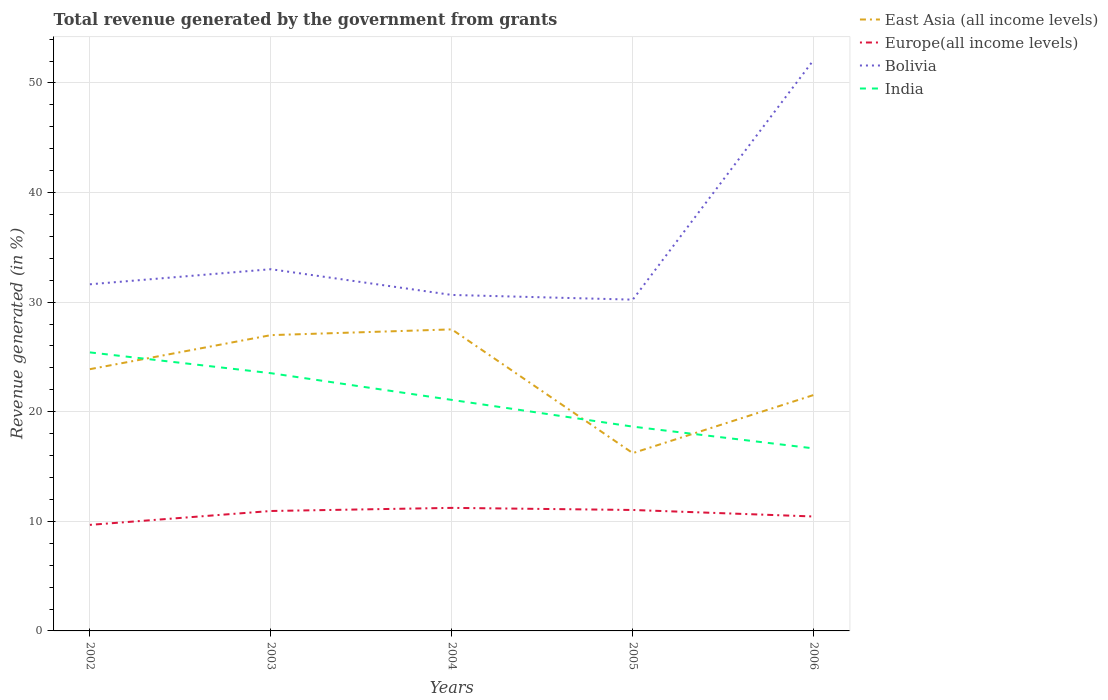How many different coloured lines are there?
Your answer should be compact. 4. Across all years, what is the maximum total revenue generated in India?
Your answer should be compact. 16.65. What is the total total revenue generated in Europe(all income levels) in the graph?
Offer a terse response. -0.76. What is the difference between the highest and the second highest total revenue generated in East Asia (all income levels)?
Your answer should be very brief. 11.29. Is the total revenue generated in India strictly greater than the total revenue generated in Bolivia over the years?
Give a very brief answer. Yes. What is the difference between two consecutive major ticks on the Y-axis?
Your response must be concise. 10. Does the graph contain any zero values?
Ensure brevity in your answer.  No. Does the graph contain grids?
Your answer should be very brief. Yes. How many legend labels are there?
Offer a very short reply. 4. What is the title of the graph?
Offer a terse response. Total revenue generated by the government from grants. What is the label or title of the Y-axis?
Provide a succinct answer. Revenue generated (in %). What is the Revenue generated (in %) of East Asia (all income levels) in 2002?
Give a very brief answer. 23.88. What is the Revenue generated (in %) of Europe(all income levels) in 2002?
Provide a succinct answer. 9.68. What is the Revenue generated (in %) of Bolivia in 2002?
Your answer should be compact. 31.63. What is the Revenue generated (in %) in India in 2002?
Ensure brevity in your answer.  25.41. What is the Revenue generated (in %) in East Asia (all income levels) in 2003?
Your response must be concise. 26.99. What is the Revenue generated (in %) of Europe(all income levels) in 2003?
Your answer should be compact. 10.94. What is the Revenue generated (in %) in Bolivia in 2003?
Keep it short and to the point. 33. What is the Revenue generated (in %) of India in 2003?
Offer a terse response. 23.52. What is the Revenue generated (in %) of East Asia (all income levels) in 2004?
Your answer should be very brief. 27.51. What is the Revenue generated (in %) in Europe(all income levels) in 2004?
Provide a succinct answer. 11.23. What is the Revenue generated (in %) in Bolivia in 2004?
Make the answer very short. 30.66. What is the Revenue generated (in %) of India in 2004?
Offer a very short reply. 21.08. What is the Revenue generated (in %) in East Asia (all income levels) in 2005?
Ensure brevity in your answer.  16.22. What is the Revenue generated (in %) of Europe(all income levels) in 2005?
Ensure brevity in your answer.  11.04. What is the Revenue generated (in %) of Bolivia in 2005?
Your answer should be compact. 30.23. What is the Revenue generated (in %) of India in 2005?
Provide a succinct answer. 18.64. What is the Revenue generated (in %) of East Asia (all income levels) in 2006?
Offer a very short reply. 21.53. What is the Revenue generated (in %) in Europe(all income levels) in 2006?
Make the answer very short. 10.44. What is the Revenue generated (in %) of Bolivia in 2006?
Your answer should be compact. 52.11. What is the Revenue generated (in %) of India in 2006?
Offer a very short reply. 16.65. Across all years, what is the maximum Revenue generated (in %) in East Asia (all income levels)?
Give a very brief answer. 27.51. Across all years, what is the maximum Revenue generated (in %) of Europe(all income levels)?
Offer a very short reply. 11.23. Across all years, what is the maximum Revenue generated (in %) in Bolivia?
Offer a very short reply. 52.11. Across all years, what is the maximum Revenue generated (in %) in India?
Your answer should be very brief. 25.41. Across all years, what is the minimum Revenue generated (in %) in East Asia (all income levels)?
Give a very brief answer. 16.22. Across all years, what is the minimum Revenue generated (in %) of Europe(all income levels)?
Offer a very short reply. 9.68. Across all years, what is the minimum Revenue generated (in %) of Bolivia?
Make the answer very short. 30.23. Across all years, what is the minimum Revenue generated (in %) of India?
Your answer should be very brief. 16.65. What is the total Revenue generated (in %) in East Asia (all income levels) in the graph?
Your response must be concise. 116.13. What is the total Revenue generated (in %) in Europe(all income levels) in the graph?
Ensure brevity in your answer.  53.32. What is the total Revenue generated (in %) in Bolivia in the graph?
Provide a short and direct response. 177.62. What is the total Revenue generated (in %) of India in the graph?
Your answer should be very brief. 105.3. What is the difference between the Revenue generated (in %) of East Asia (all income levels) in 2002 and that in 2003?
Give a very brief answer. -3.11. What is the difference between the Revenue generated (in %) of Europe(all income levels) in 2002 and that in 2003?
Provide a short and direct response. -1.27. What is the difference between the Revenue generated (in %) in Bolivia in 2002 and that in 2003?
Your response must be concise. -1.38. What is the difference between the Revenue generated (in %) in India in 2002 and that in 2003?
Offer a terse response. 1.9. What is the difference between the Revenue generated (in %) of East Asia (all income levels) in 2002 and that in 2004?
Keep it short and to the point. -3.63. What is the difference between the Revenue generated (in %) in Europe(all income levels) in 2002 and that in 2004?
Ensure brevity in your answer.  -1.55. What is the difference between the Revenue generated (in %) in India in 2002 and that in 2004?
Your response must be concise. 4.33. What is the difference between the Revenue generated (in %) of East Asia (all income levels) in 2002 and that in 2005?
Offer a terse response. 7.66. What is the difference between the Revenue generated (in %) in Europe(all income levels) in 2002 and that in 2005?
Ensure brevity in your answer.  -1.36. What is the difference between the Revenue generated (in %) of Bolivia in 2002 and that in 2005?
Offer a very short reply. 1.4. What is the difference between the Revenue generated (in %) in India in 2002 and that in 2005?
Offer a terse response. 6.77. What is the difference between the Revenue generated (in %) in East Asia (all income levels) in 2002 and that in 2006?
Provide a short and direct response. 2.35. What is the difference between the Revenue generated (in %) of Europe(all income levels) in 2002 and that in 2006?
Offer a very short reply. -0.76. What is the difference between the Revenue generated (in %) of Bolivia in 2002 and that in 2006?
Make the answer very short. -20.48. What is the difference between the Revenue generated (in %) in India in 2002 and that in 2006?
Your response must be concise. 8.76. What is the difference between the Revenue generated (in %) of East Asia (all income levels) in 2003 and that in 2004?
Provide a short and direct response. -0.52. What is the difference between the Revenue generated (in %) of Europe(all income levels) in 2003 and that in 2004?
Your answer should be very brief. -0.28. What is the difference between the Revenue generated (in %) of Bolivia in 2003 and that in 2004?
Keep it short and to the point. 2.35. What is the difference between the Revenue generated (in %) of India in 2003 and that in 2004?
Offer a terse response. 2.44. What is the difference between the Revenue generated (in %) in East Asia (all income levels) in 2003 and that in 2005?
Make the answer very short. 10.77. What is the difference between the Revenue generated (in %) of Europe(all income levels) in 2003 and that in 2005?
Your response must be concise. -0.09. What is the difference between the Revenue generated (in %) in Bolivia in 2003 and that in 2005?
Make the answer very short. 2.78. What is the difference between the Revenue generated (in %) of India in 2003 and that in 2005?
Offer a terse response. 4.88. What is the difference between the Revenue generated (in %) in East Asia (all income levels) in 2003 and that in 2006?
Offer a very short reply. 5.46. What is the difference between the Revenue generated (in %) in Europe(all income levels) in 2003 and that in 2006?
Provide a succinct answer. 0.5. What is the difference between the Revenue generated (in %) in Bolivia in 2003 and that in 2006?
Ensure brevity in your answer.  -19.1. What is the difference between the Revenue generated (in %) of India in 2003 and that in 2006?
Offer a very short reply. 6.86. What is the difference between the Revenue generated (in %) of East Asia (all income levels) in 2004 and that in 2005?
Ensure brevity in your answer.  11.29. What is the difference between the Revenue generated (in %) in Europe(all income levels) in 2004 and that in 2005?
Keep it short and to the point. 0.19. What is the difference between the Revenue generated (in %) in Bolivia in 2004 and that in 2005?
Provide a short and direct response. 0.43. What is the difference between the Revenue generated (in %) in India in 2004 and that in 2005?
Make the answer very short. 2.44. What is the difference between the Revenue generated (in %) of East Asia (all income levels) in 2004 and that in 2006?
Your answer should be compact. 5.98. What is the difference between the Revenue generated (in %) of Europe(all income levels) in 2004 and that in 2006?
Provide a short and direct response. 0.79. What is the difference between the Revenue generated (in %) in Bolivia in 2004 and that in 2006?
Provide a short and direct response. -21.45. What is the difference between the Revenue generated (in %) in India in 2004 and that in 2006?
Provide a succinct answer. 4.42. What is the difference between the Revenue generated (in %) of East Asia (all income levels) in 2005 and that in 2006?
Your answer should be compact. -5.31. What is the difference between the Revenue generated (in %) in Europe(all income levels) in 2005 and that in 2006?
Give a very brief answer. 0.59. What is the difference between the Revenue generated (in %) of Bolivia in 2005 and that in 2006?
Your response must be concise. -21.88. What is the difference between the Revenue generated (in %) of India in 2005 and that in 2006?
Offer a very short reply. 1.99. What is the difference between the Revenue generated (in %) in East Asia (all income levels) in 2002 and the Revenue generated (in %) in Europe(all income levels) in 2003?
Your response must be concise. 12.94. What is the difference between the Revenue generated (in %) of East Asia (all income levels) in 2002 and the Revenue generated (in %) of Bolivia in 2003?
Give a very brief answer. -9.12. What is the difference between the Revenue generated (in %) in East Asia (all income levels) in 2002 and the Revenue generated (in %) in India in 2003?
Offer a very short reply. 0.37. What is the difference between the Revenue generated (in %) of Europe(all income levels) in 2002 and the Revenue generated (in %) of Bolivia in 2003?
Offer a very short reply. -23.33. What is the difference between the Revenue generated (in %) of Europe(all income levels) in 2002 and the Revenue generated (in %) of India in 2003?
Your answer should be compact. -13.84. What is the difference between the Revenue generated (in %) in Bolivia in 2002 and the Revenue generated (in %) in India in 2003?
Keep it short and to the point. 8.11. What is the difference between the Revenue generated (in %) in East Asia (all income levels) in 2002 and the Revenue generated (in %) in Europe(all income levels) in 2004?
Provide a succinct answer. 12.65. What is the difference between the Revenue generated (in %) in East Asia (all income levels) in 2002 and the Revenue generated (in %) in Bolivia in 2004?
Provide a short and direct response. -6.77. What is the difference between the Revenue generated (in %) of East Asia (all income levels) in 2002 and the Revenue generated (in %) of India in 2004?
Provide a short and direct response. 2.8. What is the difference between the Revenue generated (in %) in Europe(all income levels) in 2002 and the Revenue generated (in %) in Bolivia in 2004?
Keep it short and to the point. -20.98. What is the difference between the Revenue generated (in %) of Europe(all income levels) in 2002 and the Revenue generated (in %) of India in 2004?
Provide a short and direct response. -11.4. What is the difference between the Revenue generated (in %) of Bolivia in 2002 and the Revenue generated (in %) of India in 2004?
Give a very brief answer. 10.55. What is the difference between the Revenue generated (in %) of East Asia (all income levels) in 2002 and the Revenue generated (in %) of Europe(all income levels) in 2005?
Give a very brief answer. 12.85. What is the difference between the Revenue generated (in %) in East Asia (all income levels) in 2002 and the Revenue generated (in %) in Bolivia in 2005?
Offer a very short reply. -6.34. What is the difference between the Revenue generated (in %) of East Asia (all income levels) in 2002 and the Revenue generated (in %) of India in 2005?
Provide a short and direct response. 5.24. What is the difference between the Revenue generated (in %) in Europe(all income levels) in 2002 and the Revenue generated (in %) in Bolivia in 2005?
Your response must be concise. -20.55. What is the difference between the Revenue generated (in %) in Europe(all income levels) in 2002 and the Revenue generated (in %) in India in 2005?
Provide a short and direct response. -8.96. What is the difference between the Revenue generated (in %) in Bolivia in 2002 and the Revenue generated (in %) in India in 2005?
Your answer should be compact. 12.99. What is the difference between the Revenue generated (in %) in East Asia (all income levels) in 2002 and the Revenue generated (in %) in Europe(all income levels) in 2006?
Provide a succinct answer. 13.44. What is the difference between the Revenue generated (in %) in East Asia (all income levels) in 2002 and the Revenue generated (in %) in Bolivia in 2006?
Make the answer very short. -28.23. What is the difference between the Revenue generated (in %) of East Asia (all income levels) in 2002 and the Revenue generated (in %) of India in 2006?
Provide a short and direct response. 7.23. What is the difference between the Revenue generated (in %) in Europe(all income levels) in 2002 and the Revenue generated (in %) in Bolivia in 2006?
Give a very brief answer. -42.43. What is the difference between the Revenue generated (in %) of Europe(all income levels) in 2002 and the Revenue generated (in %) of India in 2006?
Make the answer very short. -6.98. What is the difference between the Revenue generated (in %) of Bolivia in 2002 and the Revenue generated (in %) of India in 2006?
Make the answer very short. 14.97. What is the difference between the Revenue generated (in %) of East Asia (all income levels) in 2003 and the Revenue generated (in %) of Europe(all income levels) in 2004?
Your answer should be compact. 15.76. What is the difference between the Revenue generated (in %) of East Asia (all income levels) in 2003 and the Revenue generated (in %) of Bolivia in 2004?
Provide a succinct answer. -3.67. What is the difference between the Revenue generated (in %) in East Asia (all income levels) in 2003 and the Revenue generated (in %) in India in 2004?
Offer a very short reply. 5.91. What is the difference between the Revenue generated (in %) of Europe(all income levels) in 2003 and the Revenue generated (in %) of Bolivia in 2004?
Make the answer very short. -19.71. What is the difference between the Revenue generated (in %) in Europe(all income levels) in 2003 and the Revenue generated (in %) in India in 2004?
Your answer should be very brief. -10.14. What is the difference between the Revenue generated (in %) in Bolivia in 2003 and the Revenue generated (in %) in India in 2004?
Offer a terse response. 11.93. What is the difference between the Revenue generated (in %) of East Asia (all income levels) in 2003 and the Revenue generated (in %) of Europe(all income levels) in 2005?
Make the answer very short. 15.95. What is the difference between the Revenue generated (in %) of East Asia (all income levels) in 2003 and the Revenue generated (in %) of Bolivia in 2005?
Make the answer very short. -3.24. What is the difference between the Revenue generated (in %) in East Asia (all income levels) in 2003 and the Revenue generated (in %) in India in 2005?
Provide a succinct answer. 8.35. What is the difference between the Revenue generated (in %) in Europe(all income levels) in 2003 and the Revenue generated (in %) in Bolivia in 2005?
Your response must be concise. -19.28. What is the difference between the Revenue generated (in %) in Europe(all income levels) in 2003 and the Revenue generated (in %) in India in 2005?
Your response must be concise. -7.7. What is the difference between the Revenue generated (in %) in Bolivia in 2003 and the Revenue generated (in %) in India in 2005?
Keep it short and to the point. 14.36. What is the difference between the Revenue generated (in %) of East Asia (all income levels) in 2003 and the Revenue generated (in %) of Europe(all income levels) in 2006?
Make the answer very short. 16.55. What is the difference between the Revenue generated (in %) in East Asia (all income levels) in 2003 and the Revenue generated (in %) in Bolivia in 2006?
Keep it short and to the point. -25.12. What is the difference between the Revenue generated (in %) in East Asia (all income levels) in 2003 and the Revenue generated (in %) in India in 2006?
Offer a terse response. 10.33. What is the difference between the Revenue generated (in %) of Europe(all income levels) in 2003 and the Revenue generated (in %) of Bolivia in 2006?
Make the answer very short. -41.16. What is the difference between the Revenue generated (in %) of Europe(all income levels) in 2003 and the Revenue generated (in %) of India in 2006?
Offer a terse response. -5.71. What is the difference between the Revenue generated (in %) of Bolivia in 2003 and the Revenue generated (in %) of India in 2006?
Offer a terse response. 16.35. What is the difference between the Revenue generated (in %) of East Asia (all income levels) in 2004 and the Revenue generated (in %) of Europe(all income levels) in 2005?
Ensure brevity in your answer.  16.48. What is the difference between the Revenue generated (in %) in East Asia (all income levels) in 2004 and the Revenue generated (in %) in Bolivia in 2005?
Ensure brevity in your answer.  -2.71. What is the difference between the Revenue generated (in %) of East Asia (all income levels) in 2004 and the Revenue generated (in %) of India in 2005?
Give a very brief answer. 8.87. What is the difference between the Revenue generated (in %) in Europe(all income levels) in 2004 and the Revenue generated (in %) in Bolivia in 2005?
Your answer should be compact. -19. What is the difference between the Revenue generated (in %) of Europe(all income levels) in 2004 and the Revenue generated (in %) of India in 2005?
Your answer should be compact. -7.41. What is the difference between the Revenue generated (in %) of Bolivia in 2004 and the Revenue generated (in %) of India in 2005?
Provide a short and direct response. 12.02. What is the difference between the Revenue generated (in %) of East Asia (all income levels) in 2004 and the Revenue generated (in %) of Europe(all income levels) in 2006?
Ensure brevity in your answer.  17.07. What is the difference between the Revenue generated (in %) of East Asia (all income levels) in 2004 and the Revenue generated (in %) of Bolivia in 2006?
Ensure brevity in your answer.  -24.59. What is the difference between the Revenue generated (in %) in East Asia (all income levels) in 2004 and the Revenue generated (in %) in India in 2006?
Your answer should be compact. 10.86. What is the difference between the Revenue generated (in %) of Europe(all income levels) in 2004 and the Revenue generated (in %) of Bolivia in 2006?
Make the answer very short. -40.88. What is the difference between the Revenue generated (in %) in Europe(all income levels) in 2004 and the Revenue generated (in %) in India in 2006?
Offer a very short reply. -5.43. What is the difference between the Revenue generated (in %) of Bolivia in 2004 and the Revenue generated (in %) of India in 2006?
Your answer should be very brief. 14. What is the difference between the Revenue generated (in %) in East Asia (all income levels) in 2005 and the Revenue generated (in %) in Europe(all income levels) in 2006?
Make the answer very short. 5.78. What is the difference between the Revenue generated (in %) in East Asia (all income levels) in 2005 and the Revenue generated (in %) in Bolivia in 2006?
Make the answer very short. -35.88. What is the difference between the Revenue generated (in %) in East Asia (all income levels) in 2005 and the Revenue generated (in %) in India in 2006?
Provide a succinct answer. -0.43. What is the difference between the Revenue generated (in %) of Europe(all income levels) in 2005 and the Revenue generated (in %) of Bolivia in 2006?
Provide a short and direct response. -41.07. What is the difference between the Revenue generated (in %) in Europe(all income levels) in 2005 and the Revenue generated (in %) in India in 2006?
Make the answer very short. -5.62. What is the difference between the Revenue generated (in %) in Bolivia in 2005 and the Revenue generated (in %) in India in 2006?
Provide a succinct answer. 13.57. What is the average Revenue generated (in %) in East Asia (all income levels) per year?
Provide a short and direct response. 23.23. What is the average Revenue generated (in %) in Europe(all income levels) per year?
Keep it short and to the point. 10.66. What is the average Revenue generated (in %) in Bolivia per year?
Provide a succinct answer. 35.52. What is the average Revenue generated (in %) in India per year?
Provide a short and direct response. 21.06. In the year 2002, what is the difference between the Revenue generated (in %) in East Asia (all income levels) and Revenue generated (in %) in Europe(all income levels)?
Offer a terse response. 14.21. In the year 2002, what is the difference between the Revenue generated (in %) in East Asia (all income levels) and Revenue generated (in %) in Bolivia?
Make the answer very short. -7.75. In the year 2002, what is the difference between the Revenue generated (in %) of East Asia (all income levels) and Revenue generated (in %) of India?
Your answer should be very brief. -1.53. In the year 2002, what is the difference between the Revenue generated (in %) in Europe(all income levels) and Revenue generated (in %) in Bolivia?
Provide a short and direct response. -21.95. In the year 2002, what is the difference between the Revenue generated (in %) in Europe(all income levels) and Revenue generated (in %) in India?
Offer a very short reply. -15.74. In the year 2002, what is the difference between the Revenue generated (in %) of Bolivia and Revenue generated (in %) of India?
Keep it short and to the point. 6.21. In the year 2003, what is the difference between the Revenue generated (in %) in East Asia (all income levels) and Revenue generated (in %) in Europe(all income levels)?
Make the answer very short. 16.05. In the year 2003, what is the difference between the Revenue generated (in %) in East Asia (all income levels) and Revenue generated (in %) in Bolivia?
Your answer should be very brief. -6.01. In the year 2003, what is the difference between the Revenue generated (in %) of East Asia (all income levels) and Revenue generated (in %) of India?
Keep it short and to the point. 3.47. In the year 2003, what is the difference between the Revenue generated (in %) of Europe(all income levels) and Revenue generated (in %) of Bolivia?
Provide a short and direct response. -22.06. In the year 2003, what is the difference between the Revenue generated (in %) of Europe(all income levels) and Revenue generated (in %) of India?
Offer a terse response. -12.57. In the year 2003, what is the difference between the Revenue generated (in %) in Bolivia and Revenue generated (in %) in India?
Your answer should be compact. 9.49. In the year 2004, what is the difference between the Revenue generated (in %) in East Asia (all income levels) and Revenue generated (in %) in Europe(all income levels)?
Keep it short and to the point. 16.29. In the year 2004, what is the difference between the Revenue generated (in %) of East Asia (all income levels) and Revenue generated (in %) of Bolivia?
Give a very brief answer. -3.14. In the year 2004, what is the difference between the Revenue generated (in %) in East Asia (all income levels) and Revenue generated (in %) in India?
Give a very brief answer. 6.43. In the year 2004, what is the difference between the Revenue generated (in %) of Europe(all income levels) and Revenue generated (in %) of Bolivia?
Offer a very short reply. -19.43. In the year 2004, what is the difference between the Revenue generated (in %) of Europe(all income levels) and Revenue generated (in %) of India?
Make the answer very short. -9.85. In the year 2004, what is the difference between the Revenue generated (in %) of Bolivia and Revenue generated (in %) of India?
Offer a terse response. 9.58. In the year 2005, what is the difference between the Revenue generated (in %) of East Asia (all income levels) and Revenue generated (in %) of Europe(all income levels)?
Your answer should be compact. 5.19. In the year 2005, what is the difference between the Revenue generated (in %) of East Asia (all income levels) and Revenue generated (in %) of Bolivia?
Ensure brevity in your answer.  -14. In the year 2005, what is the difference between the Revenue generated (in %) of East Asia (all income levels) and Revenue generated (in %) of India?
Give a very brief answer. -2.42. In the year 2005, what is the difference between the Revenue generated (in %) in Europe(all income levels) and Revenue generated (in %) in Bolivia?
Offer a terse response. -19.19. In the year 2005, what is the difference between the Revenue generated (in %) in Europe(all income levels) and Revenue generated (in %) in India?
Offer a terse response. -7.6. In the year 2005, what is the difference between the Revenue generated (in %) in Bolivia and Revenue generated (in %) in India?
Ensure brevity in your answer.  11.59. In the year 2006, what is the difference between the Revenue generated (in %) of East Asia (all income levels) and Revenue generated (in %) of Europe(all income levels)?
Offer a terse response. 11.09. In the year 2006, what is the difference between the Revenue generated (in %) of East Asia (all income levels) and Revenue generated (in %) of Bolivia?
Your answer should be compact. -30.58. In the year 2006, what is the difference between the Revenue generated (in %) of East Asia (all income levels) and Revenue generated (in %) of India?
Your response must be concise. 4.88. In the year 2006, what is the difference between the Revenue generated (in %) in Europe(all income levels) and Revenue generated (in %) in Bolivia?
Provide a succinct answer. -41.67. In the year 2006, what is the difference between the Revenue generated (in %) in Europe(all income levels) and Revenue generated (in %) in India?
Provide a short and direct response. -6.21. In the year 2006, what is the difference between the Revenue generated (in %) of Bolivia and Revenue generated (in %) of India?
Your response must be concise. 35.45. What is the ratio of the Revenue generated (in %) of East Asia (all income levels) in 2002 to that in 2003?
Keep it short and to the point. 0.88. What is the ratio of the Revenue generated (in %) in Europe(all income levels) in 2002 to that in 2003?
Your answer should be very brief. 0.88. What is the ratio of the Revenue generated (in %) in Bolivia in 2002 to that in 2003?
Your answer should be compact. 0.96. What is the ratio of the Revenue generated (in %) in India in 2002 to that in 2003?
Ensure brevity in your answer.  1.08. What is the ratio of the Revenue generated (in %) of East Asia (all income levels) in 2002 to that in 2004?
Give a very brief answer. 0.87. What is the ratio of the Revenue generated (in %) of Europe(all income levels) in 2002 to that in 2004?
Ensure brevity in your answer.  0.86. What is the ratio of the Revenue generated (in %) in Bolivia in 2002 to that in 2004?
Your response must be concise. 1.03. What is the ratio of the Revenue generated (in %) in India in 2002 to that in 2004?
Your answer should be compact. 1.21. What is the ratio of the Revenue generated (in %) of East Asia (all income levels) in 2002 to that in 2005?
Ensure brevity in your answer.  1.47. What is the ratio of the Revenue generated (in %) of Europe(all income levels) in 2002 to that in 2005?
Ensure brevity in your answer.  0.88. What is the ratio of the Revenue generated (in %) of Bolivia in 2002 to that in 2005?
Offer a very short reply. 1.05. What is the ratio of the Revenue generated (in %) of India in 2002 to that in 2005?
Offer a very short reply. 1.36. What is the ratio of the Revenue generated (in %) of East Asia (all income levels) in 2002 to that in 2006?
Offer a terse response. 1.11. What is the ratio of the Revenue generated (in %) of Europe(all income levels) in 2002 to that in 2006?
Offer a very short reply. 0.93. What is the ratio of the Revenue generated (in %) of Bolivia in 2002 to that in 2006?
Make the answer very short. 0.61. What is the ratio of the Revenue generated (in %) of India in 2002 to that in 2006?
Your answer should be very brief. 1.53. What is the ratio of the Revenue generated (in %) of East Asia (all income levels) in 2003 to that in 2004?
Provide a succinct answer. 0.98. What is the ratio of the Revenue generated (in %) in Europe(all income levels) in 2003 to that in 2004?
Keep it short and to the point. 0.97. What is the ratio of the Revenue generated (in %) in Bolivia in 2003 to that in 2004?
Keep it short and to the point. 1.08. What is the ratio of the Revenue generated (in %) of India in 2003 to that in 2004?
Your response must be concise. 1.12. What is the ratio of the Revenue generated (in %) in East Asia (all income levels) in 2003 to that in 2005?
Offer a terse response. 1.66. What is the ratio of the Revenue generated (in %) of Europe(all income levels) in 2003 to that in 2005?
Make the answer very short. 0.99. What is the ratio of the Revenue generated (in %) of Bolivia in 2003 to that in 2005?
Make the answer very short. 1.09. What is the ratio of the Revenue generated (in %) of India in 2003 to that in 2005?
Keep it short and to the point. 1.26. What is the ratio of the Revenue generated (in %) in East Asia (all income levels) in 2003 to that in 2006?
Offer a very short reply. 1.25. What is the ratio of the Revenue generated (in %) in Europe(all income levels) in 2003 to that in 2006?
Offer a very short reply. 1.05. What is the ratio of the Revenue generated (in %) in Bolivia in 2003 to that in 2006?
Your answer should be compact. 0.63. What is the ratio of the Revenue generated (in %) in India in 2003 to that in 2006?
Your response must be concise. 1.41. What is the ratio of the Revenue generated (in %) of East Asia (all income levels) in 2004 to that in 2005?
Offer a terse response. 1.7. What is the ratio of the Revenue generated (in %) in Europe(all income levels) in 2004 to that in 2005?
Offer a terse response. 1.02. What is the ratio of the Revenue generated (in %) of Bolivia in 2004 to that in 2005?
Your answer should be compact. 1.01. What is the ratio of the Revenue generated (in %) in India in 2004 to that in 2005?
Your response must be concise. 1.13. What is the ratio of the Revenue generated (in %) in East Asia (all income levels) in 2004 to that in 2006?
Your response must be concise. 1.28. What is the ratio of the Revenue generated (in %) in Europe(all income levels) in 2004 to that in 2006?
Make the answer very short. 1.08. What is the ratio of the Revenue generated (in %) of Bolivia in 2004 to that in 2006?
Offer a terse response. 0.59. What is the ratio of the Revenue generated (in %) in India in 2004 to that in 2006?
Your response must be concise. 1.27. What is the ratio of the Revenue generated (in %) in East Asia (all income levels) in 2005 to that in 2006?
Offer a terse response. 0.75. What is the ratio of the Revenue generated (in %) of Europe(all income levels) in 2005 to that in 2006?
Provide a succinct answer. 1.06. What is the ratio of the Revenue generated (in %) of Bolivia in 2005 to that in 2006?
Your answer should be compact. 0.58. What is the ratio of the Revenue generated (in %) in India in 2005 to that in 2006?
Give a very brief answer. 1.12. What is the difference between the highest and the second highest Revenue generated (in %) of East Asia (all income levels)?
Your response must be concise. 0.52. What is the difference between the highest and the second highest Revenue generated (in %) in Europe(all income levels)?
Provide a short and direct response. 0.19. What is the difference between the highest and the second highest Revenue generated (in %) of Bolivia?
Give a very brief answer. 19.1. What is the difference between the highest and the second highest Revenue generated (in %) of India?
Your answer should be very brief. 1.9. What is the difference between the highest and the lowest Revenue generated (in %) of East Asia (all income levels)?
Offer a terse response. 11.29. What is the difference between the highest and the lowest Revenue generated (in %) of Europe(all income levels)?
Offer a terse response. 1.55. What is the difference between the highest and the lowest Revenue generated (in %) in Bolivia?
Your response must be concise. 21.88. What is the difference between the highest and the lowest Revenue generated (in %) in India?
Your response must be concise. 8.76. 